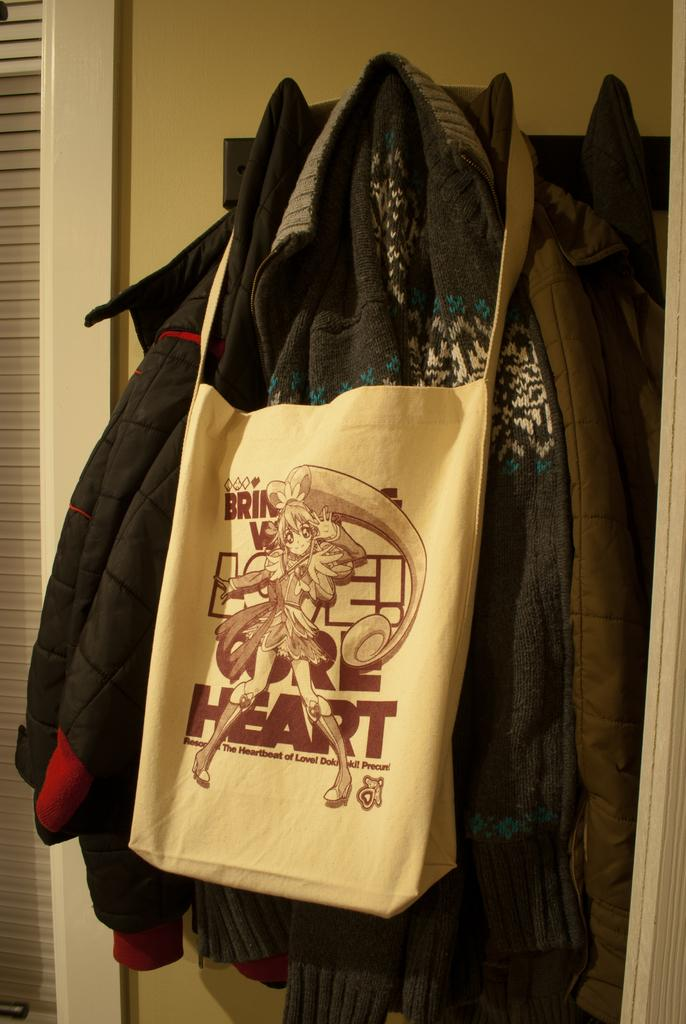What is hanging on the hanger in the image? There is a bag hanging on a hanger in the image. What else is on the hanger besides the bag? There are clothes on the hanger in the image. What can be seen in the background of the image? There is a wall visible in the background of the image. Where is the brain located in the image? There is no brain present in the image. What type of bucket can be seen in the image? There is no bucket present in the image. 